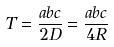Convert formula to latex. <formula><loc_0><loc_0><loc_500><loc_500>T = \frac { a b c } { 2 D } = \frac { a b c } { 4 R }</formula> 